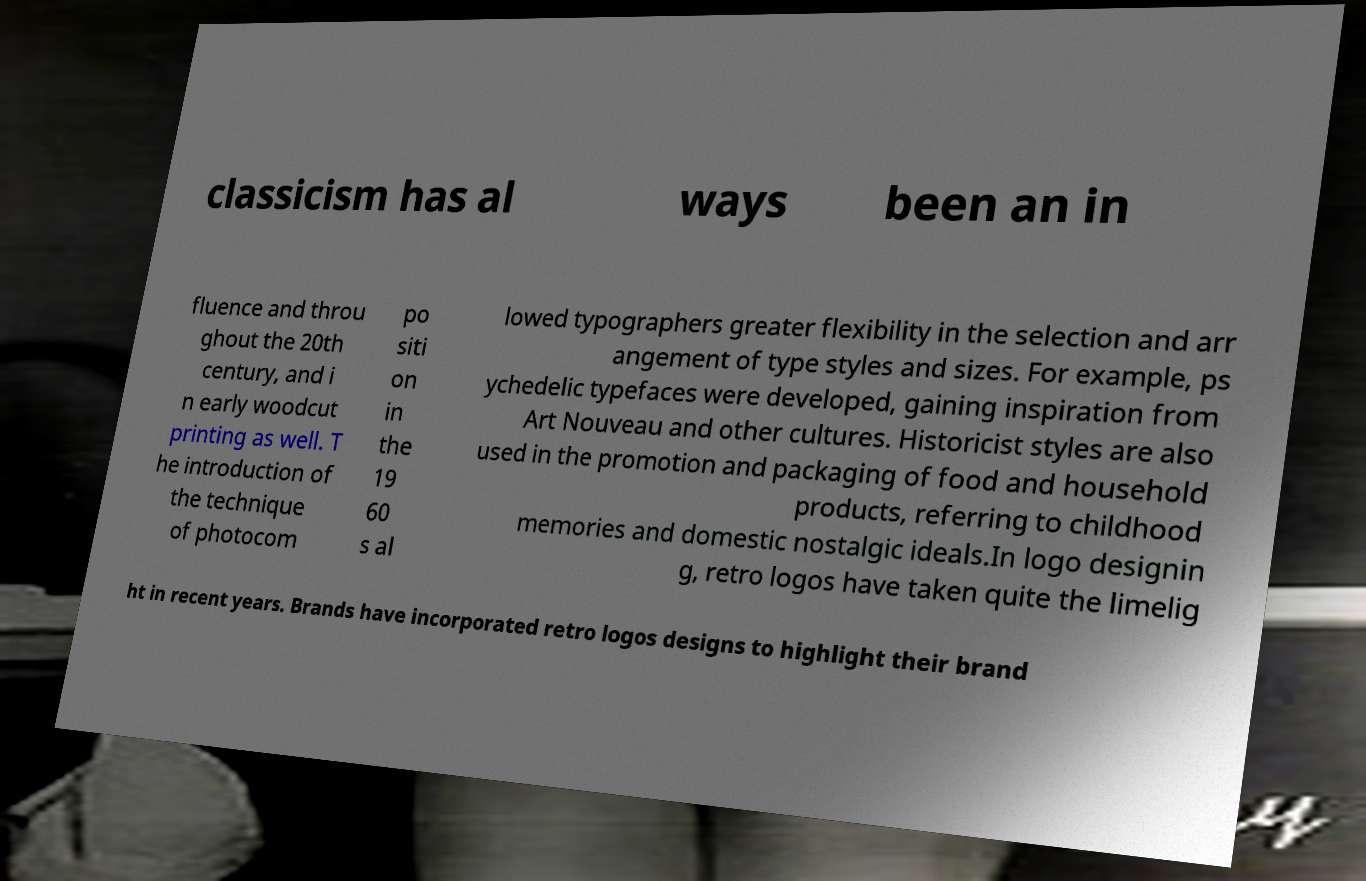I need the written content from this picture converted into text. Can you do that? classicism has al ways been an in fluence and throu ghout the 20th century, and i n early woodcut printing as well. T he introduction of the technique of photocom po siti on in the 19 60 s al lowed typographers greater flexibility in the selection and arr angement of type styles and sizes. For example, ps ychedelic typefaces were developed, gaining inspiration from Art Nouveau and other cultures. Historicist styles are also used in the promotion and packaging of food and household products, referring to childhood memories and domestic nostalgic ideals.In logo designin g, retro logos have taken quite the limelig ht in recent years. Brands have incorporated retro logos designs to highlight their brand 